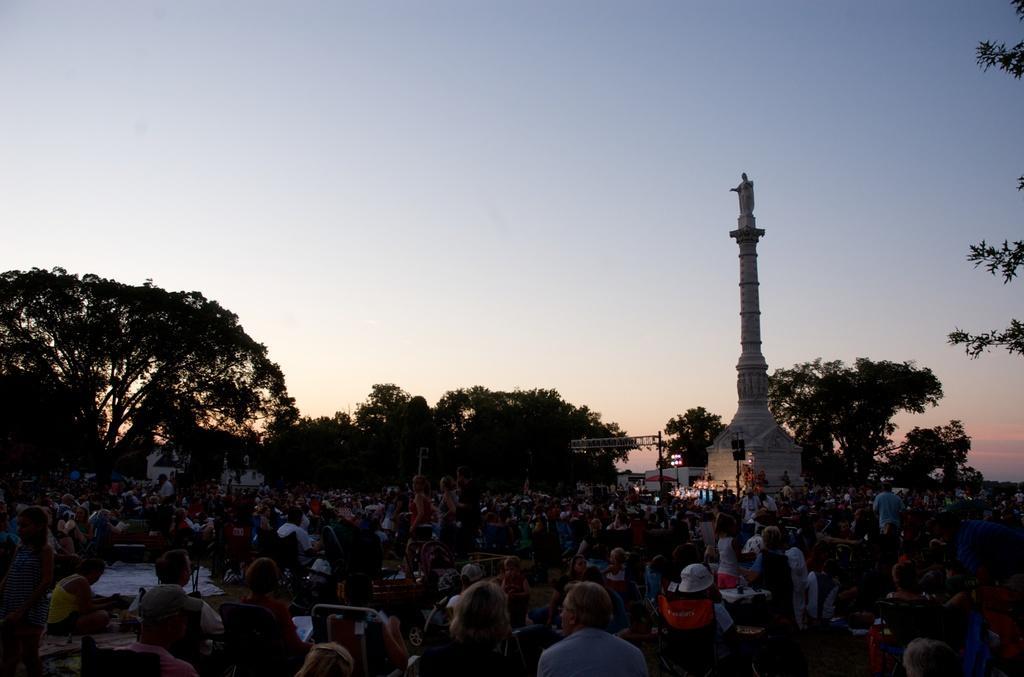How would you summarize this image in a sentence or two? There is a crowd at the bottom of this image and there are some trees in the background. There is a memorial on the right side of this image and there is a sky at the top of this image. 